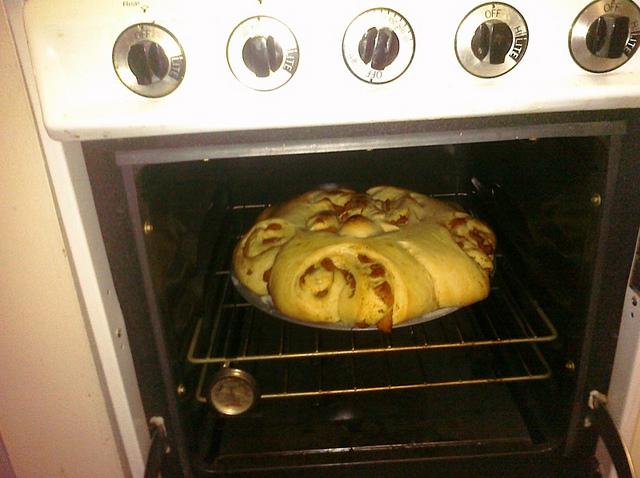Can you cook this?
Answer briefly. Yes. What kind of appliance is this?
Write a very short answer. Oven. Is this a brand new appliance?
Give a very brief answer. No. 